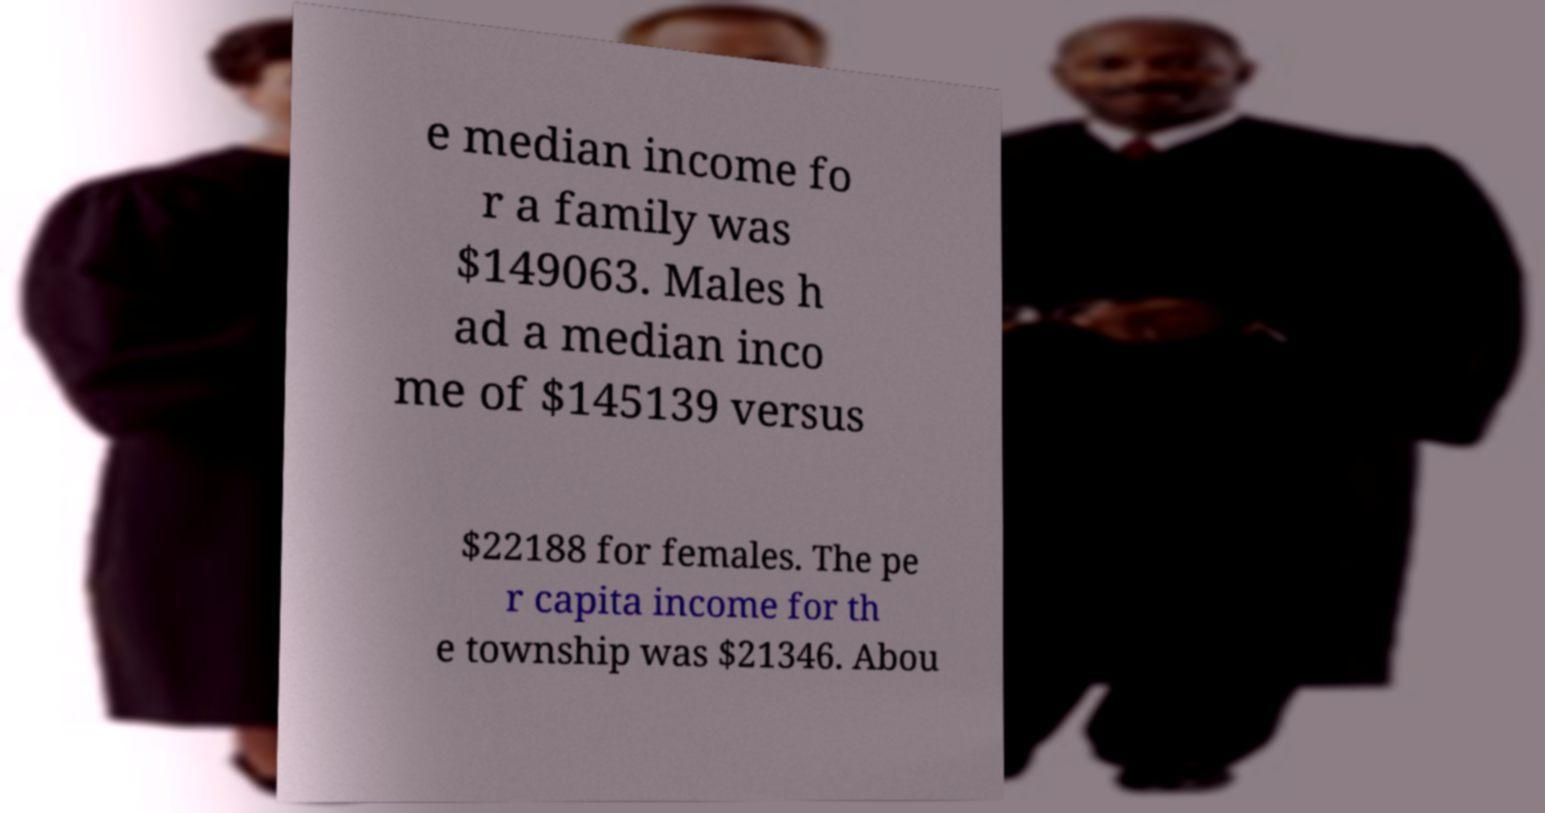Can you read and provide the text displayed in the image?This photo seems to have some interesting text. Can you extract and type it out for me? e median income fo r a family was $149063. Males h ad a median inco me of $145139 versus $22188 for females. The pe r capita income for th e township was $21346. Abou 